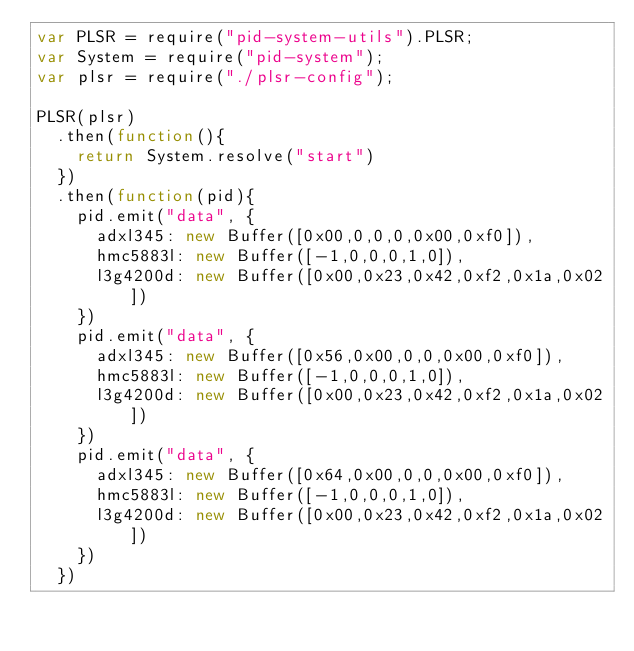Convert code to text. <code><loc_0><loc_0><loc_500><loc_500><_JavaScript_>var PLSR = require("pid-system-utils").PLSR;
var System = require("pid-system");
var plsr = require("./plsr-config");

PLSR(plsr)
  .then(function(){
    return System.resolve("start")
  })
  .then(function(pid){
    pid.emit("data", {
      adxl345: new Buffer([0x00,0,0,0,0x00,0xf0]),
      hmc5883l: new Buffer([-1,0,0,0,1,0]),
      l3g4200d: new Buffer([0x00,0x23,0x42,0xf2,0x1a,0x02])
    })
    pid.emit("data", {
      adxl345: new Buffer([0x56,0x00,0,0,0x00,0xf0]),
      hmc5883l: new Buffer([-1,0,0,0,1,0]),
      l3g4200d: new Buffer([0x00,0x23,0x42,0xf2,0x1a,0x02])
    })
    pid.emit("data", {
      adxl345: new Buffer([0x64,0x00,0,0,0x00,0xf0]),
      hmc5883l: new Buffer([-1,0,0,0,1,0]),
      l3g4200d: new Buffer([0x00,0x23,0x42,0xf2,0x1a,0x02])
    })
  })
</code> 